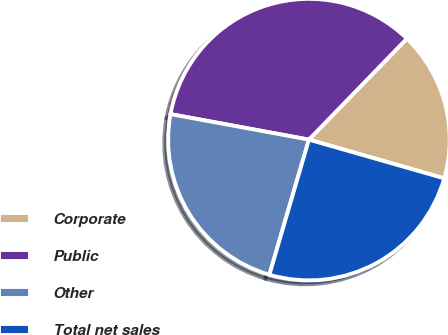<chart> <loc_0><loc_0><loc_500><loc_500><pie_chart><fcel>Corporate<fcel>Public<fcel>Other<fcel>Total net sales<nl><fcel>17.18%<fcel>34.36%<fcel>23.37%<fcel>25.09%<nl></chart> 